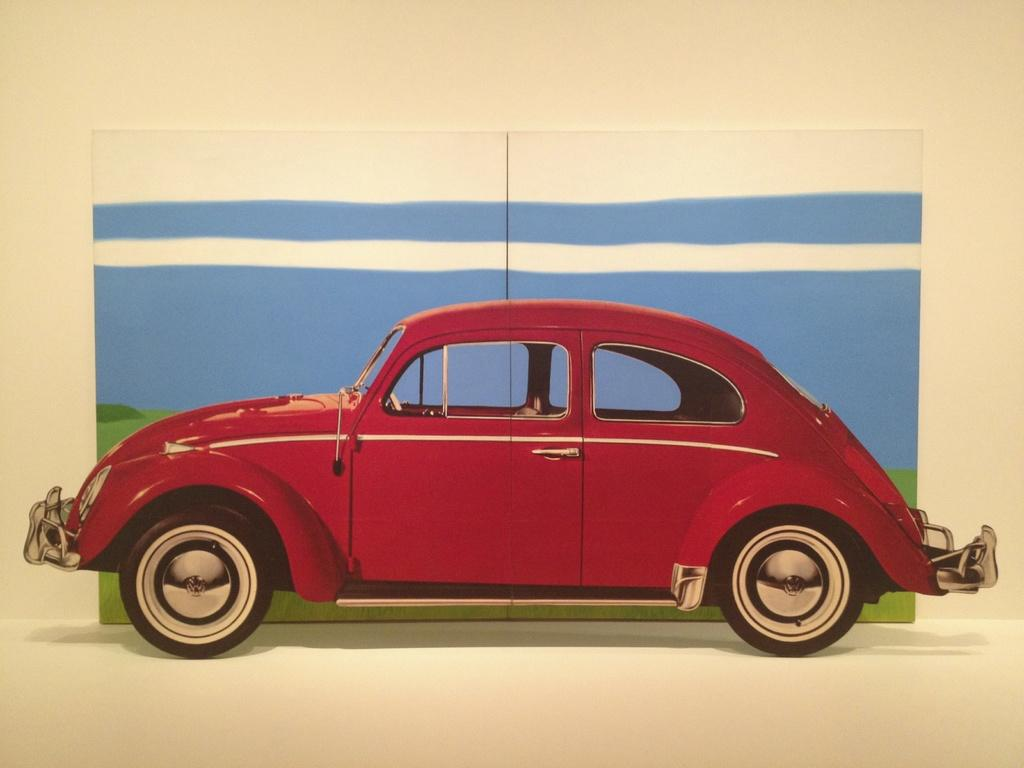What type of toy is present in the image? There is a toy car in the image. What can be seen on the surface in the image? There are objects on a surface in the image. What type of structure is visible in the image? There is a wall in the image. What type of gun is being used to reason with the toy car in the image? There is no gun or any form of reasoning present in the image; it only features a toy car and objects on a surface. 